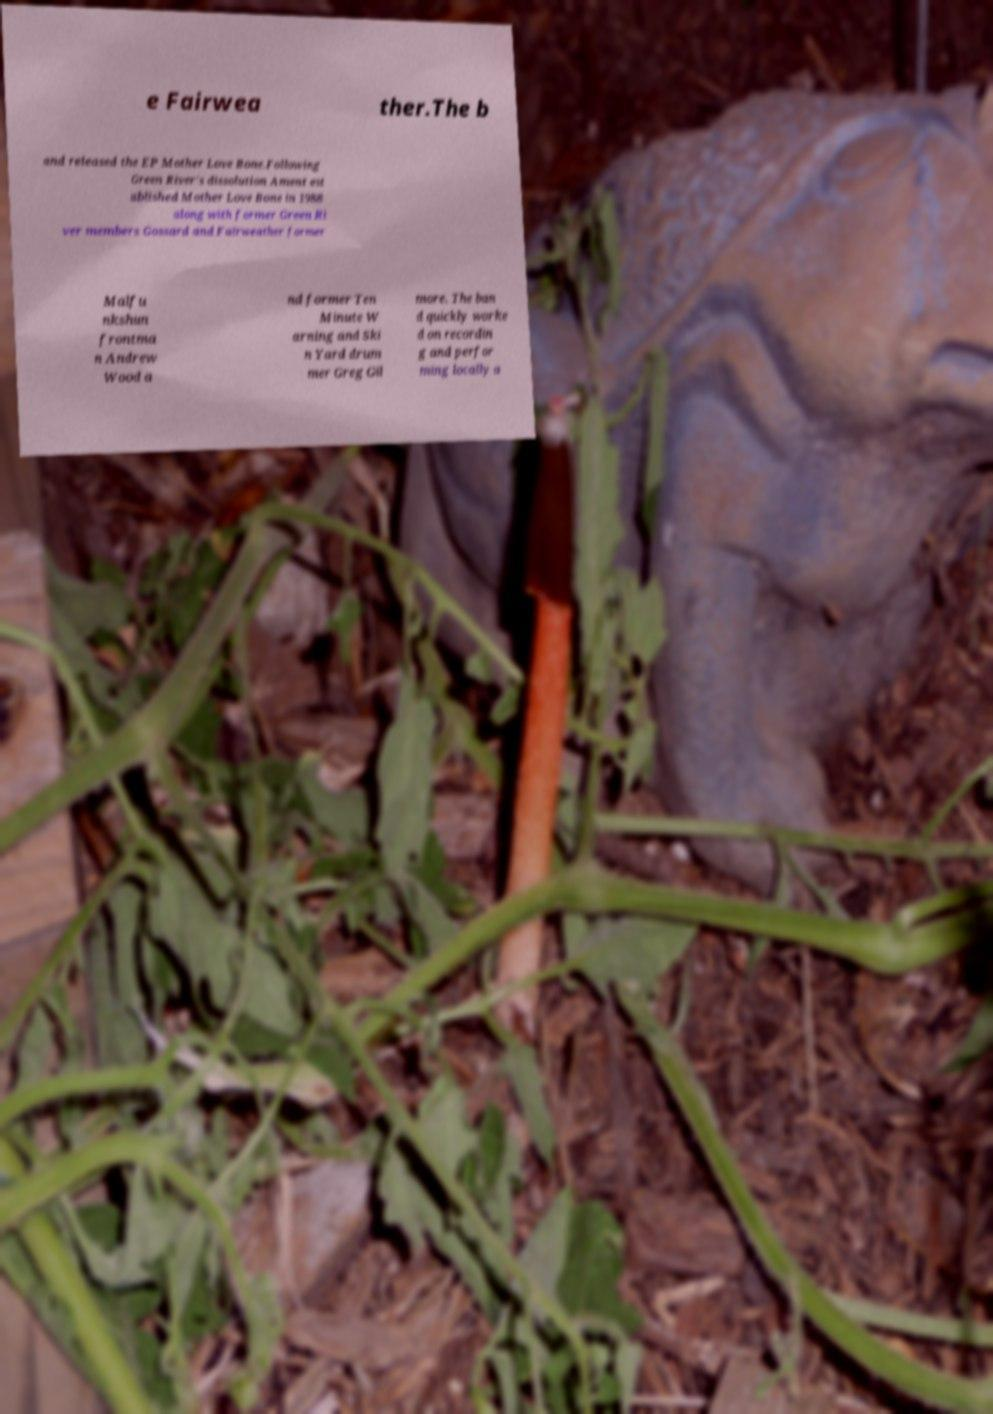Please read and relay the text visible in this image. What does it say? e Fairwea ther.The b and released the EP Mother Love Bone.Following Green River's dissolution Ament est ablished Mother Love Bone in 1988 along with former Green Ri ver members Gossard and Fairweather former Malfu nkshun frontma n Andrew Wood a nd former Ten Minute W arning and Ski n Yard drum mer Greg Gil more. The ban d quickly worke d on recordin g and perfor ming locally a 